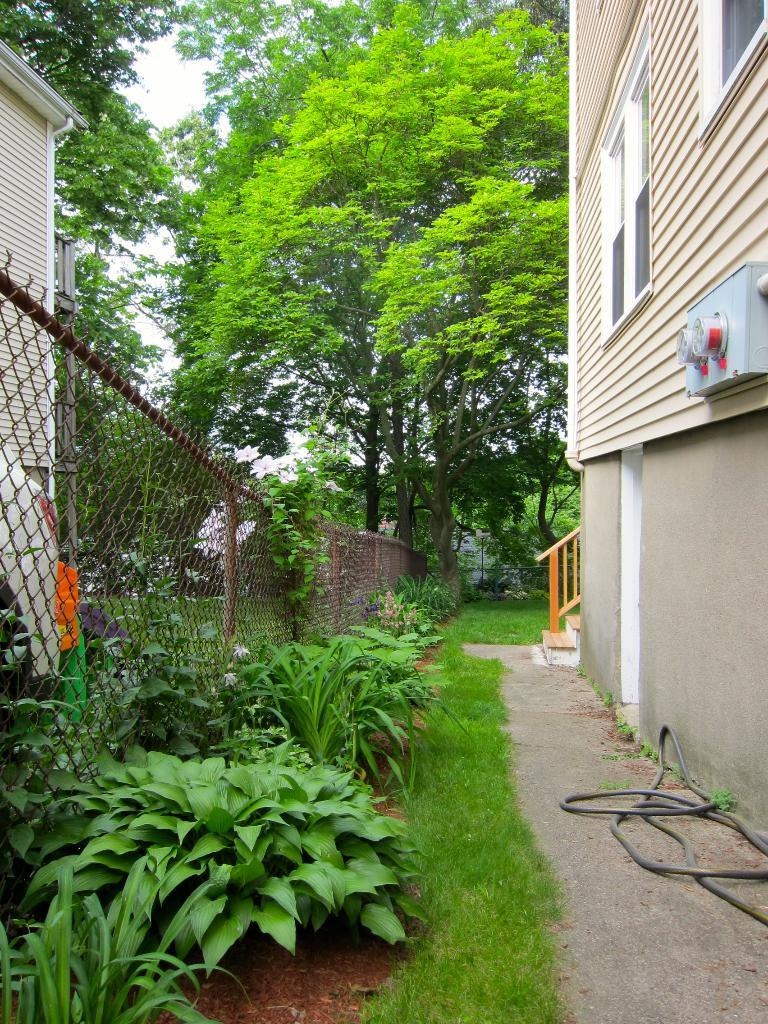What type of natural elements can be seen in the image? There are plants and trees in the image. What man-made structure is present in the image? There is a building in the image. What type of barrier can be seen in the image? There is a fence in the image. What part of the natural environment is visible in the image? The sky is visible in the image. How many dolls are playing with the boys in the image? There are no dolls or boys present in the image. What is the value of the item in the image? The provided facts do not mention any specific item or its value. 